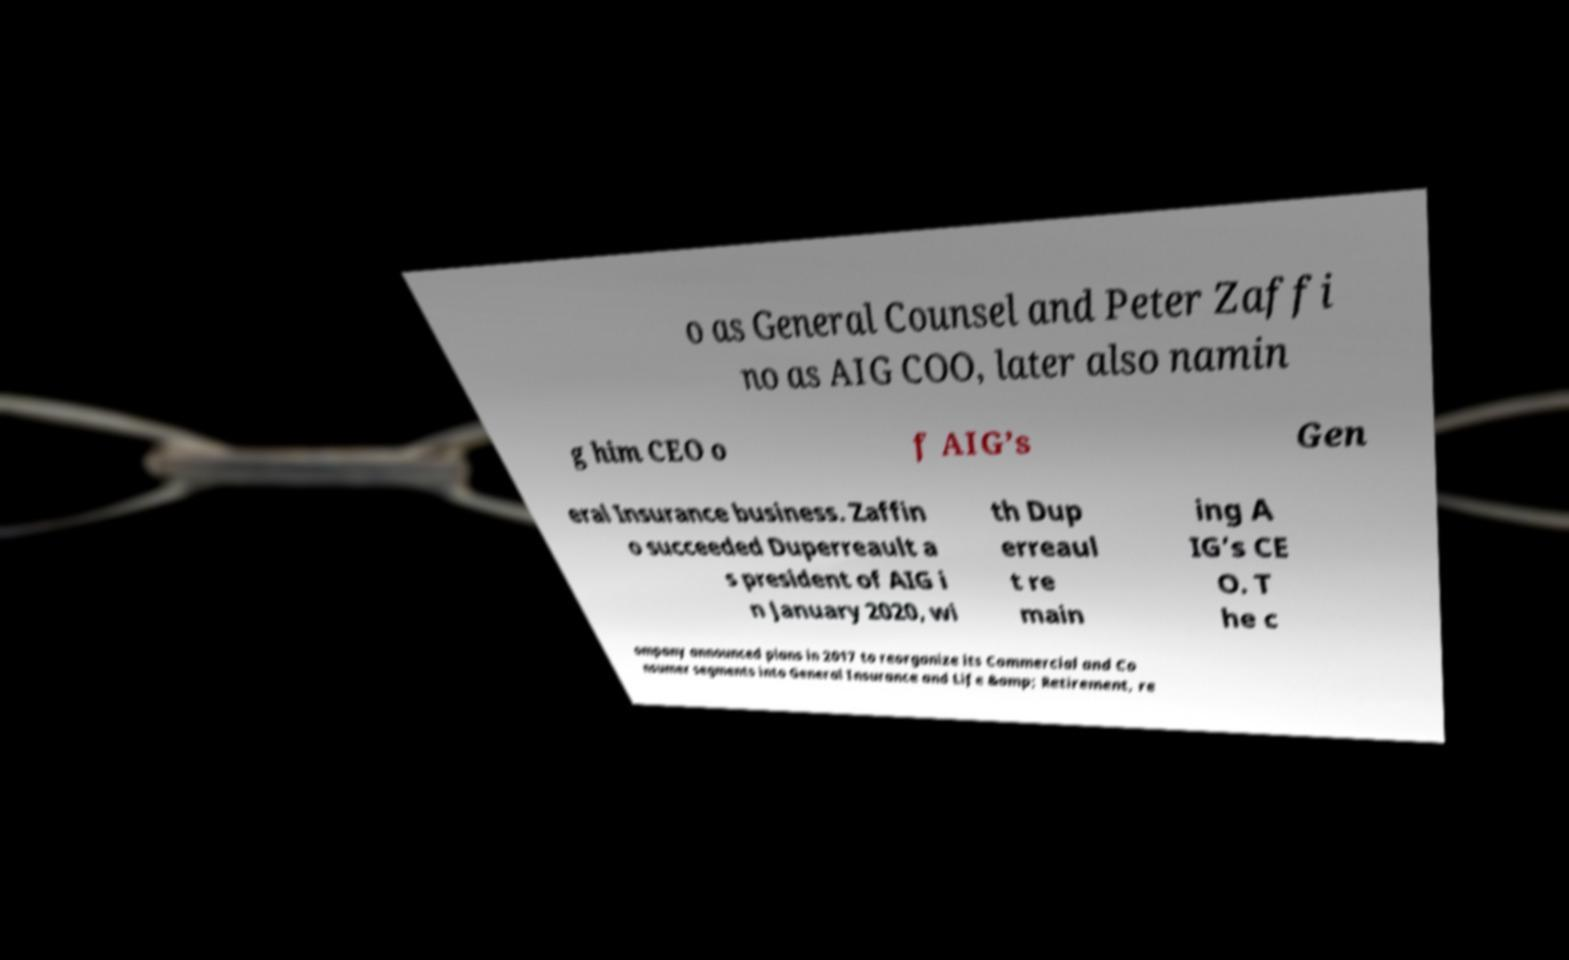Can you accurately transcribe the text from the provided image for me? o as General Counsel and Peter Zaffi no as AIG COO, later also namin g him CEO o f AIG’s Gen eral Insurance business. Zaffin o succeeded Duperreault a s president of AIG i n January 2020, wi th Dup erreaul t re main ing A IG’s CE O. T he c ompany announced plans in 2017 to reorganize its Commercial and Co nsumer segments into General Insurance and Life &amp; Retirement, re 